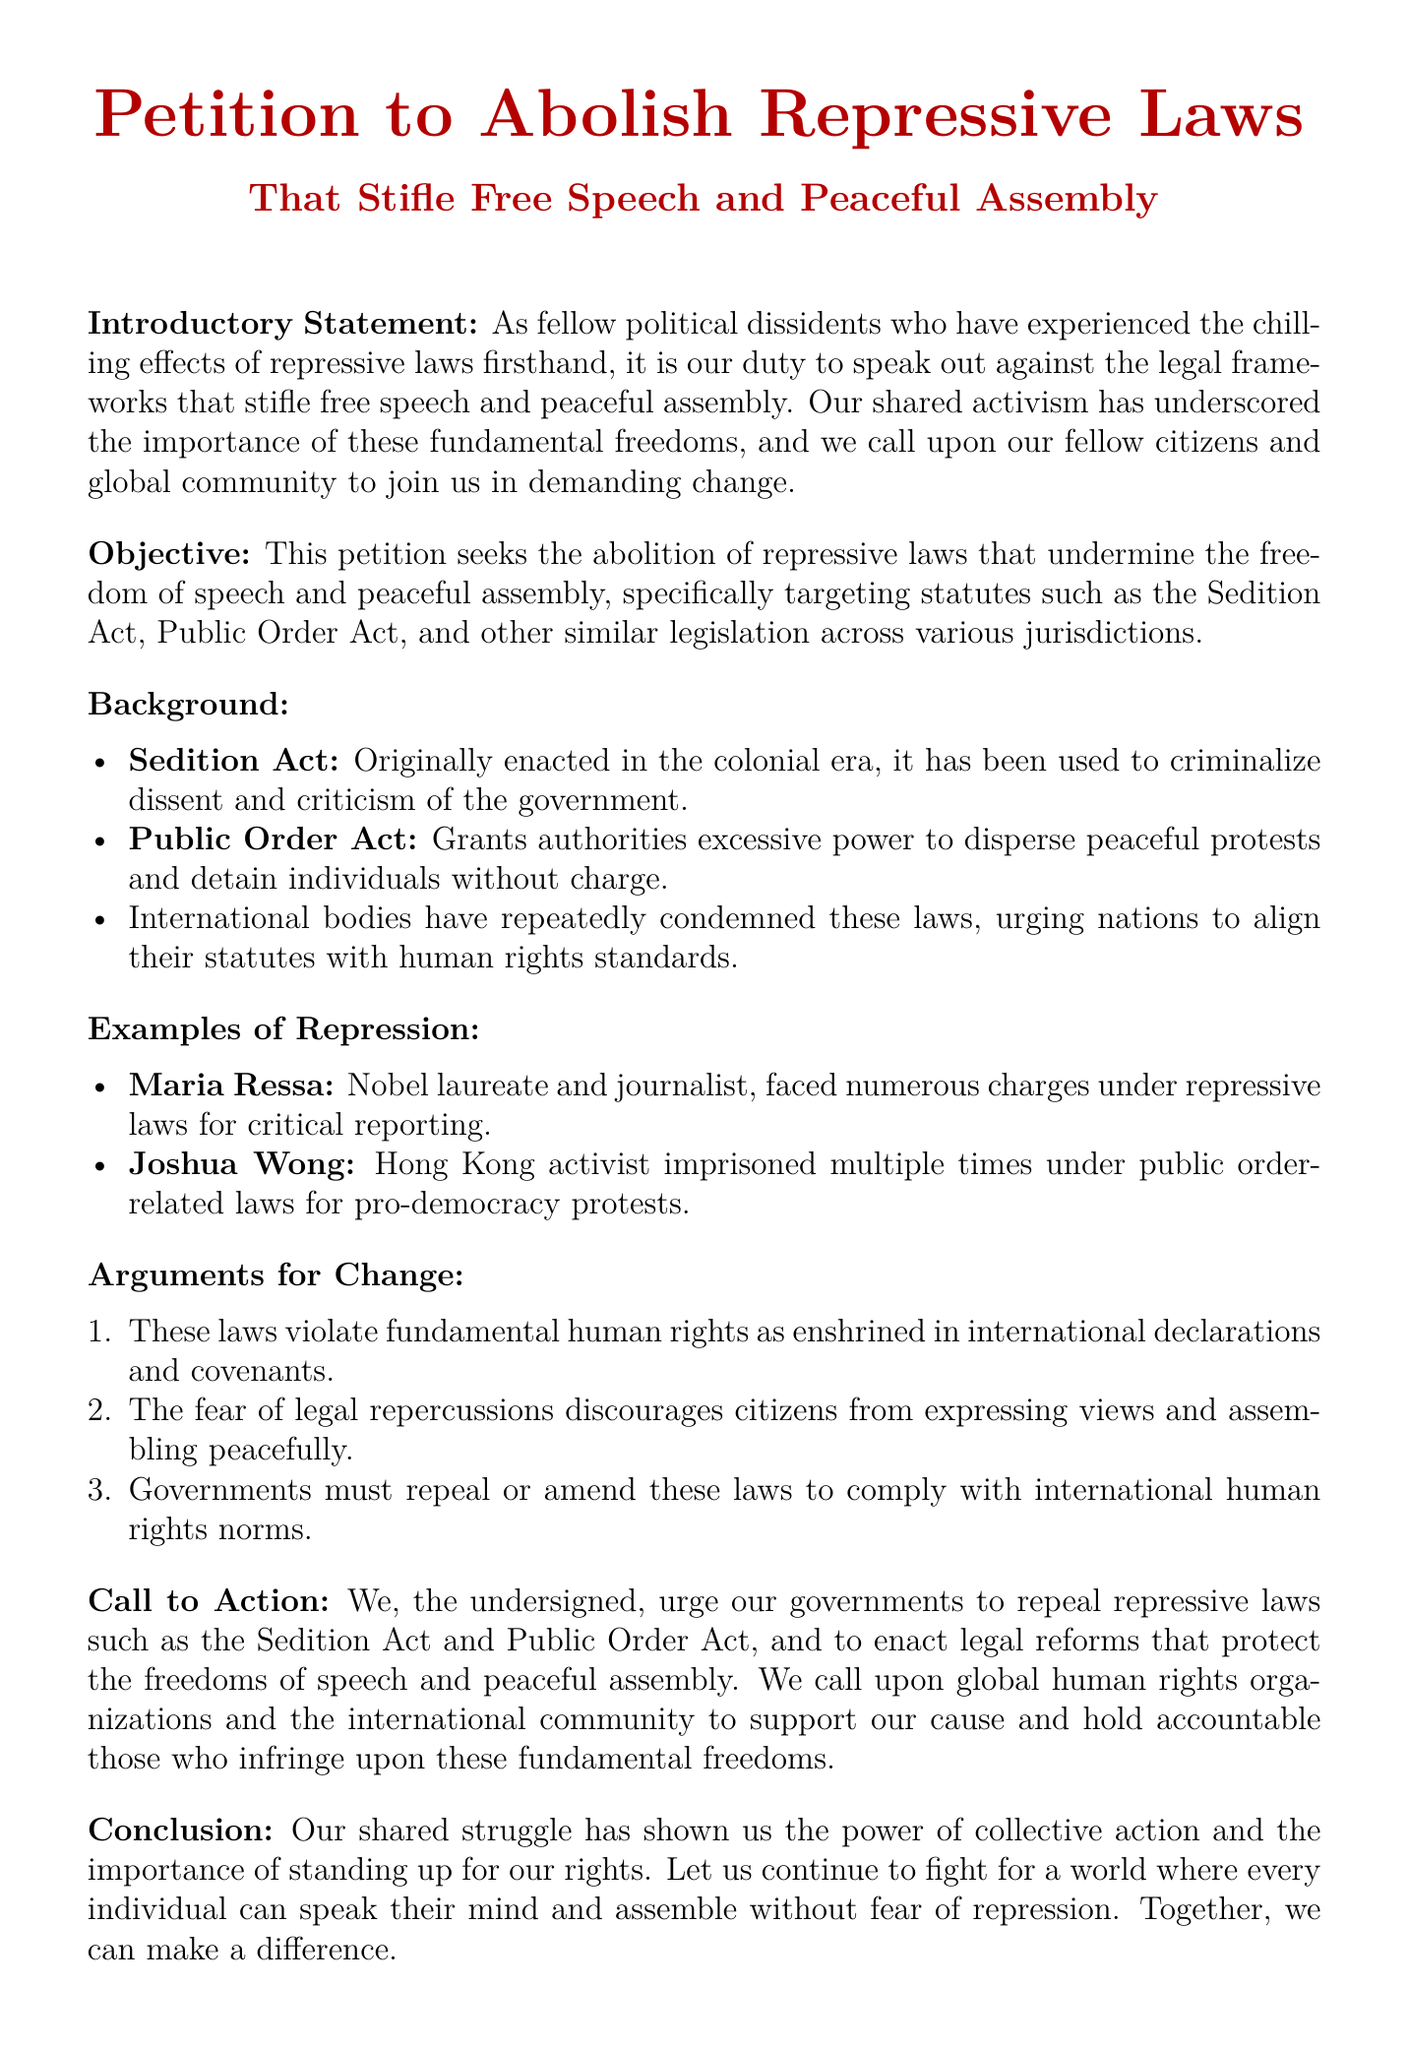What is the main purpose of the petition? The main purpose is to abolish repressive laws that undermine the freedom of speech and peaceful assembly.
Answer: Abolish repressive laws Which two laws are specifically targeted in the petition? The petition specifically targets the Sedition Act and the Public Order Act.
Answer: Sedition Act and Public Order Act Who is mentioned as a Nobel laureate facing charges under repressive laws? Maria Ressa is mentioned as a Nobel laureate faced with charges under repressive laws for critical reporting.
Answer: Maria Ressa What action does the petition urge governments to take? The petition urges governments to repeal repressive laws such as the Sedition Act and Public Order Act.
Answer: Repeal repressive laws What is a key argument for change mentioned in the document? A key argument is that these laws violate fundamental human rights as enshrined in international declarations and covenants.
Answer: Violate fundamental human rights What type of document is this? The document is a petition.
Answer: Petition 